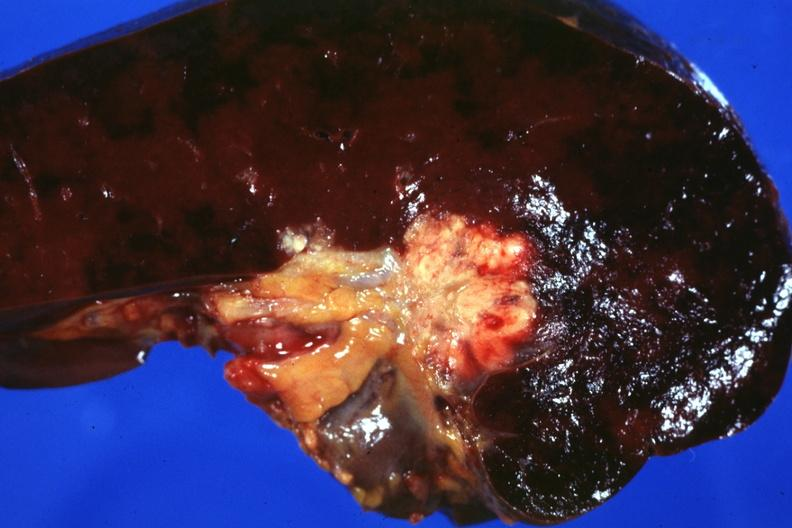s benign cystic teratoma present?
Answer the question using a single word or phrase. No 